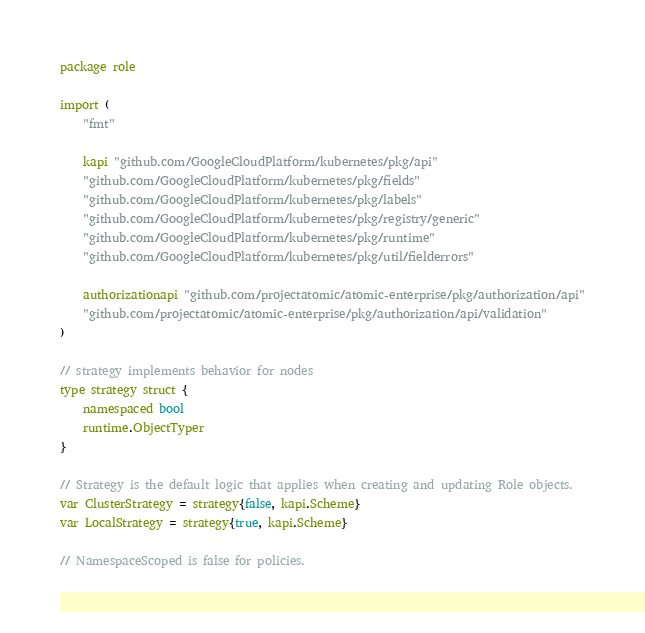<code> <loc_0><loc_0><loc_500><loc_500><_Go_>package role

import (
	"fmt"

	kapi "github.com/GoogleCloudPlatform/kubernetes/pkg/api"
	"github.com/GoogleCloudPlatform/kubernetes/pkg/fields"
	"github.com/GoogleCloudPlatform/kubernetes/pkg/labels"
	"github.com/GoogleCloudPlatform/kubernetes/pkg/registry/generic"
	"github.com/GoogleCloudPlatform/kubernetes/pkg/runtime"
	"github.com/GoogleCloudPlatform/kubernetes/pkg/util/fielderrors"

	authorizationapi "github.com/projectatomic/atomic-enterprise/pkg/authorization/api"
	"github.com/projectatomic/atomic-enterprise/pkg/authorization/api/validation"
)

// strategy implements behavior for nodes
type strategy struct {
	namespaced bool
	runtime.ObjectTyper
}

// Strategy is the default logic that applies when creating and updating Role objects.
var ClusterStrategy = strategy{false, kapi.Scheme}
var LocalStrategy = strategy{true, kapi.Scheme}

// NamespaceScoped is false for policies.</code> 